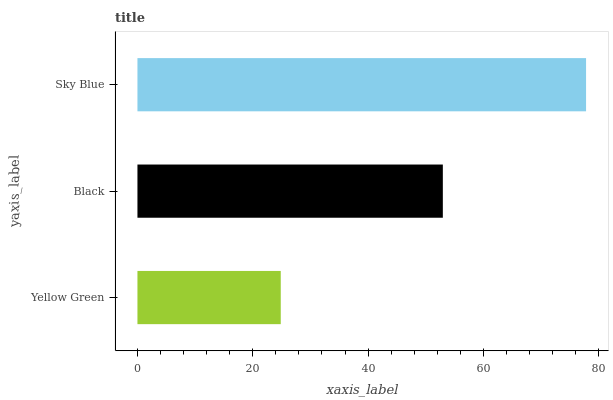Is Yellow Green the minimum?
Answer yes or no. Yes. Is Sky Blue the maximum?
Answer yes or no. Yes. Is Black the minimum?
Answer yes or no. No. Is Black the maximum?
Answer yes or no. No. Is Black greater than Yellow Green?
Answer yes or no. Yes. Is Yellow Green less than Black?
Answer yes or no. Yes. Is Yellow Green greater than Black?
Answer yes or no. No. Is Black less than Yellow Green?
Answer yes or no. No. Is Black the high median?
Answer yes or no. Yes. Is Black the low median?
Answer yes or no. Yes. Is Yellow Green the high median?
Answer yes or no. No. Is Yellow Green the low median?
Answer yes or no. No. 